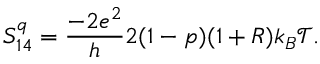<formula> <loc_0><loc_0><loc_500><loc_500>S _ { 1 4 } ^ { q } = \frac { - 2 e ^ { 2 } } { h } 2 ( 1 - p ) ( 1 + R ) k _ { B } \mathcal { T } .</formula> 